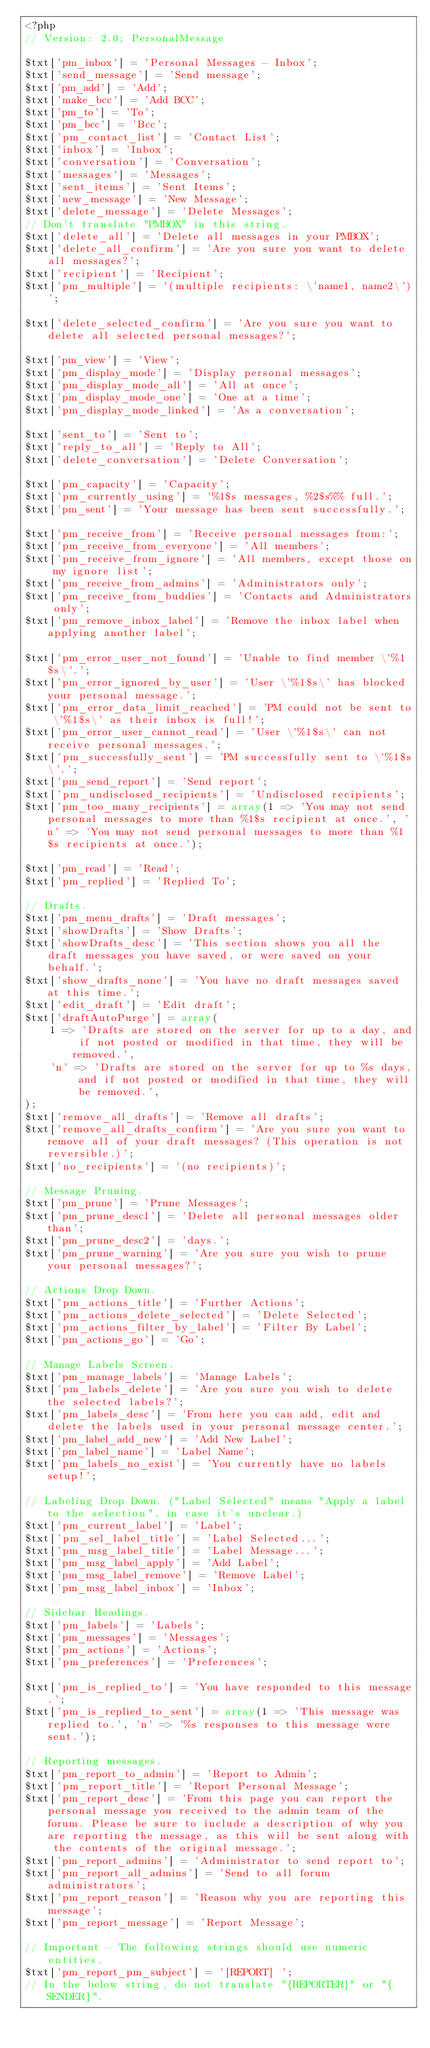<code> <loc_0><loc_0><loc_500><loc_500><_PHP_><?php
// Version: 2.0; PersonalMessage

$txt['pm_inbox'] = 'Personal Messages - Inbox';
$txt['send_message'] = 'Send message';
$txt['pm_add'] = 'Add';
$txt['make_bcc'] = 'Add BCC';
$txt['pm_to'] = 'To';
$txt['pm_bcc'] = 'Bcc';
$txt['pm_contact_list'] = 'Contact List';
$txt['inbox'] = 'Inbox';
$txt['conversation'] = 'Conversation';
$txt['messages'] = 'Messages';
$txt['sent_items'] = 'Sent Items';
$txt['new_message'] = 'New Message';
$txt['delete_message'] = 'Delete Messages';
// Don't translate "PMBOX" in this string.
$txt['delete_all'] = 'Delete all messages in your PMBOX';
$txt['delete_all_confirm'] = 'Are you sure you want to delete all messages?';
$txt['recipient'] = 'Recipient';
$txt['pm_multiple'] = '(multiple recipients: \'name1, name2\')';

$txt['delete_selected_confirm'] = 'Are you sure you want to delete all selected personal messages?';

$txt['pm_view'] = 'View';
$txt['pm_display_mode'] = 'Display personal messages';
$txt['pm_display_mode_all'] = 'All at once';
$txt['pm_display_mode_one'] = 'One at a time';
$txt['pm_display_mode_linked'] = 'As a conversation';

$txt['sent_to'] = 'Sent to';
$txt['reply_to_all'] = 'Reply to All';
$txt['delete_conversation'] = 'Delete Conversation';

$txt['pm_capacity'] = 'Capacity';
$txt['pm_currently_using'] = '%1$s messages, %2$s%% full.';
$txt['pm_sent'] = 'Your message has been sent successfully.';

$txt['pm_receive_from'] = 'Receive personal messages from:';
$txt['pm_receive_from_everyone'] = 'All members';
$txt['pm_receive_from_ignore'] = 'All members, except those on my ignore list';
$txt['pm_receive_from_admins'] = 'Administrators only';
$txt['pm_receive_from_buddies'] = 'Contacts and Administrators only';
$txt['pm_remove_inbox_label'] = 'Remove the inbox label when applying another label';

$txt['pm_error_user_not_found'] = 'Unable to find member \'%1$s\'.';
$txt['pm_error_ignored_by_user'] = 'User \'%1$s\' has blocked your personal message.';
$txt['pm_error_data_limit_reached'] = 'PM could not be sent to \'%1$s\' as their inbox is full!';
$txt['pm_error_user_cannot_read'] = 'User \'%1$s\' can not receive personal messages.';
$txt['pm_successfully_sent'] = 'PM successfully sent to \'%1$s\'.';
$txt['pm_send_report'] = 'Send report';
$txt['pm_undisclosed_recipients'] = 'Undisclosed recipients';
$txt['pm_too_many_recipients'] = array(1 => 'You may not send personal messages to more than %1$s recipient at once.', 'n' => 'You may not send personal messages to more than %1$s recipients at once.');

$txt['pm_read'] = 'Read';
$txt['pm_replied'] = 'Replied To';

// Drafts.
$txt['pm_menu_drafts'] = 'Draft messages';
$txt['showDrafts'] = 'Show Drafts';
$txt['showDrafts_desc'] = 'This section shows you all the draft messages you have saved, or were saved on your behalf.';
$txt['show_drafts_none'] = 'You have no draft messages saved at this time.';
$txt['edit_draft'] = 'Edit draft';
$txt['draftAutoPurge'] = array(
	1 => 'Drafts are stored on the server for up to a day, and if not posted or modified in that time, they will be removed.',
	'n' => 'Drafts are stored on the server for up to %s days, and if not posted or modified in that time, they will be removed.',
);
$txt['remove_all_drafts'] = 'Remove all drafts';
$txt['remove_all_drafts_confirm'] = 'Are you sure you want to remove all of your draft messages? (This operation is not reversible.)';
$txt['no_recipients'] = '(no recipients)';

// Message Pruning.
$txt['pm_prune'] = 'Prune Messages';
$txt['pm_prune_desc1'] = 'Delete all personal messages older than';
$txt['pm_prune_desc2'] = 'days.';
$txt['pm_prune_warning'] = 'Are you sure you wish to prune your personal messages?';

// Actions Drop Down.
$txt['pm_actions_title'] = 'Further Actions';
$txt['pm_actions_delete_selected'] = 'Delete Selected';
$txt['pm_actions_filter_by_label'] = 'Filter By Label';
$txt['pm_actions_go'] = 'Go';

// Manage Labels Screen.
$txt['pm_manage_labels'] = 'Manage Labels';
$txt['pm_labels_delete'] = 'Are you sure you wish to delete the selected labels?';
$txt['pm_labels_desc'] = 'From here you can add, edit and delete the labels used in your personal message center.';
$txt['pm_label_add_new'] = 'Add New Label';
$txt['pm_label_name'] = 'Label Name';
$txt['pm_labels_no_exist'] = 'You currently have no labels setup!';

// Labeling Drop Down. ("Label Selected" means "Apply a label to the selection", in case it's unclear.)
$txt['pm_current_label'] = 'Label';
$txt['pm_sel_label_title'] = 'Label Selected...';
$txt['pm_msg_label_title'] = 'Label Message...';
$txt['pm_msg_label_apply'] = 'Add Label';
$txt['pm_msg_label_remove'] = 'Remove Label';
$txt['pm_msg_label_inbox'] = 'Inbox';

// Sidebar Headings.
$txt['pm_labels'] = 'Labels';
$txt['pm_messages'] = 'Messages';
$txt['pm_actions'] = 'Actions';
$txt['pm_preferences'] = 'Preferences';

$txt['pm_is_replied_to'] = 'You have responded to this message.';
$txt['pm_is_replied_to_sent'] = array(1 => 'This message was replied to.', 'n' => '%s responses to this message were sent.');

// Reporting messages.
$txt['pm_report_to_admin'] = 'Report to Admin';
$txt['pm_report_title'] = 'Report Personal Message';
$txt['pm_report_desc'] = 'From this page you can report the personal message you received to the admin team of the forum. Please be sure to include a description of why you are reporting the message, as this will be sent along with the contents of the original message.';
$txt['pm_report_admins'] = 'Administrator to send report to';
$txt['pm_report_all_admins'] = 'Send to all forum administrators';
$txt['pm_report_reason'] = 'Reason why you are reporting this message';
$txt['pm_report_message'] = 'Report Message';

// Important - The following strings should use numeric entities.
$txt['pm_report_pm_subject'] = '[REPORT] ';
// In the below string, do not translate "{REPORTER}" or "{SENDER}".</code> 